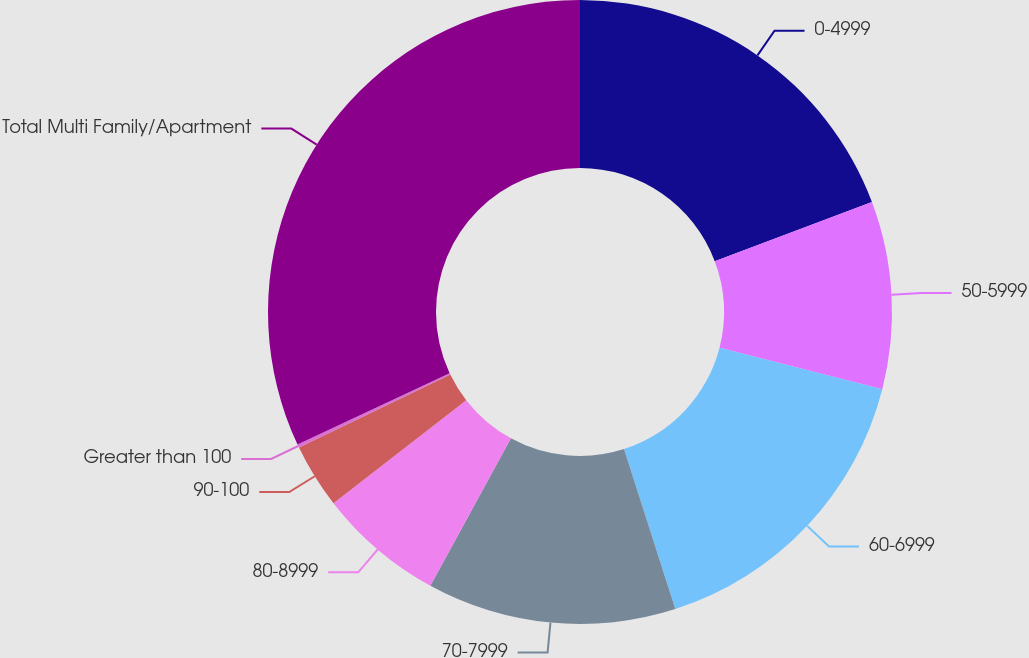Convert chart. <chart><loc_0><loc_0><loc_500><loc_500><pie_chart><fcel>0-4999<fcel>50-5999<fcel>60-6999<fcel>70-7999<fcel>80-8999<fcel>90-100<fcel>Greater than 100<fcel>Total Multi Family/Apartment<nl><fcel>19.26%<fcel>9.72%<fcel>16.08%<fcel>12.9%<fcel>6.54%<fcel>3.35%<fcel>0.17%<fcel>31.98%<nl></chart> 